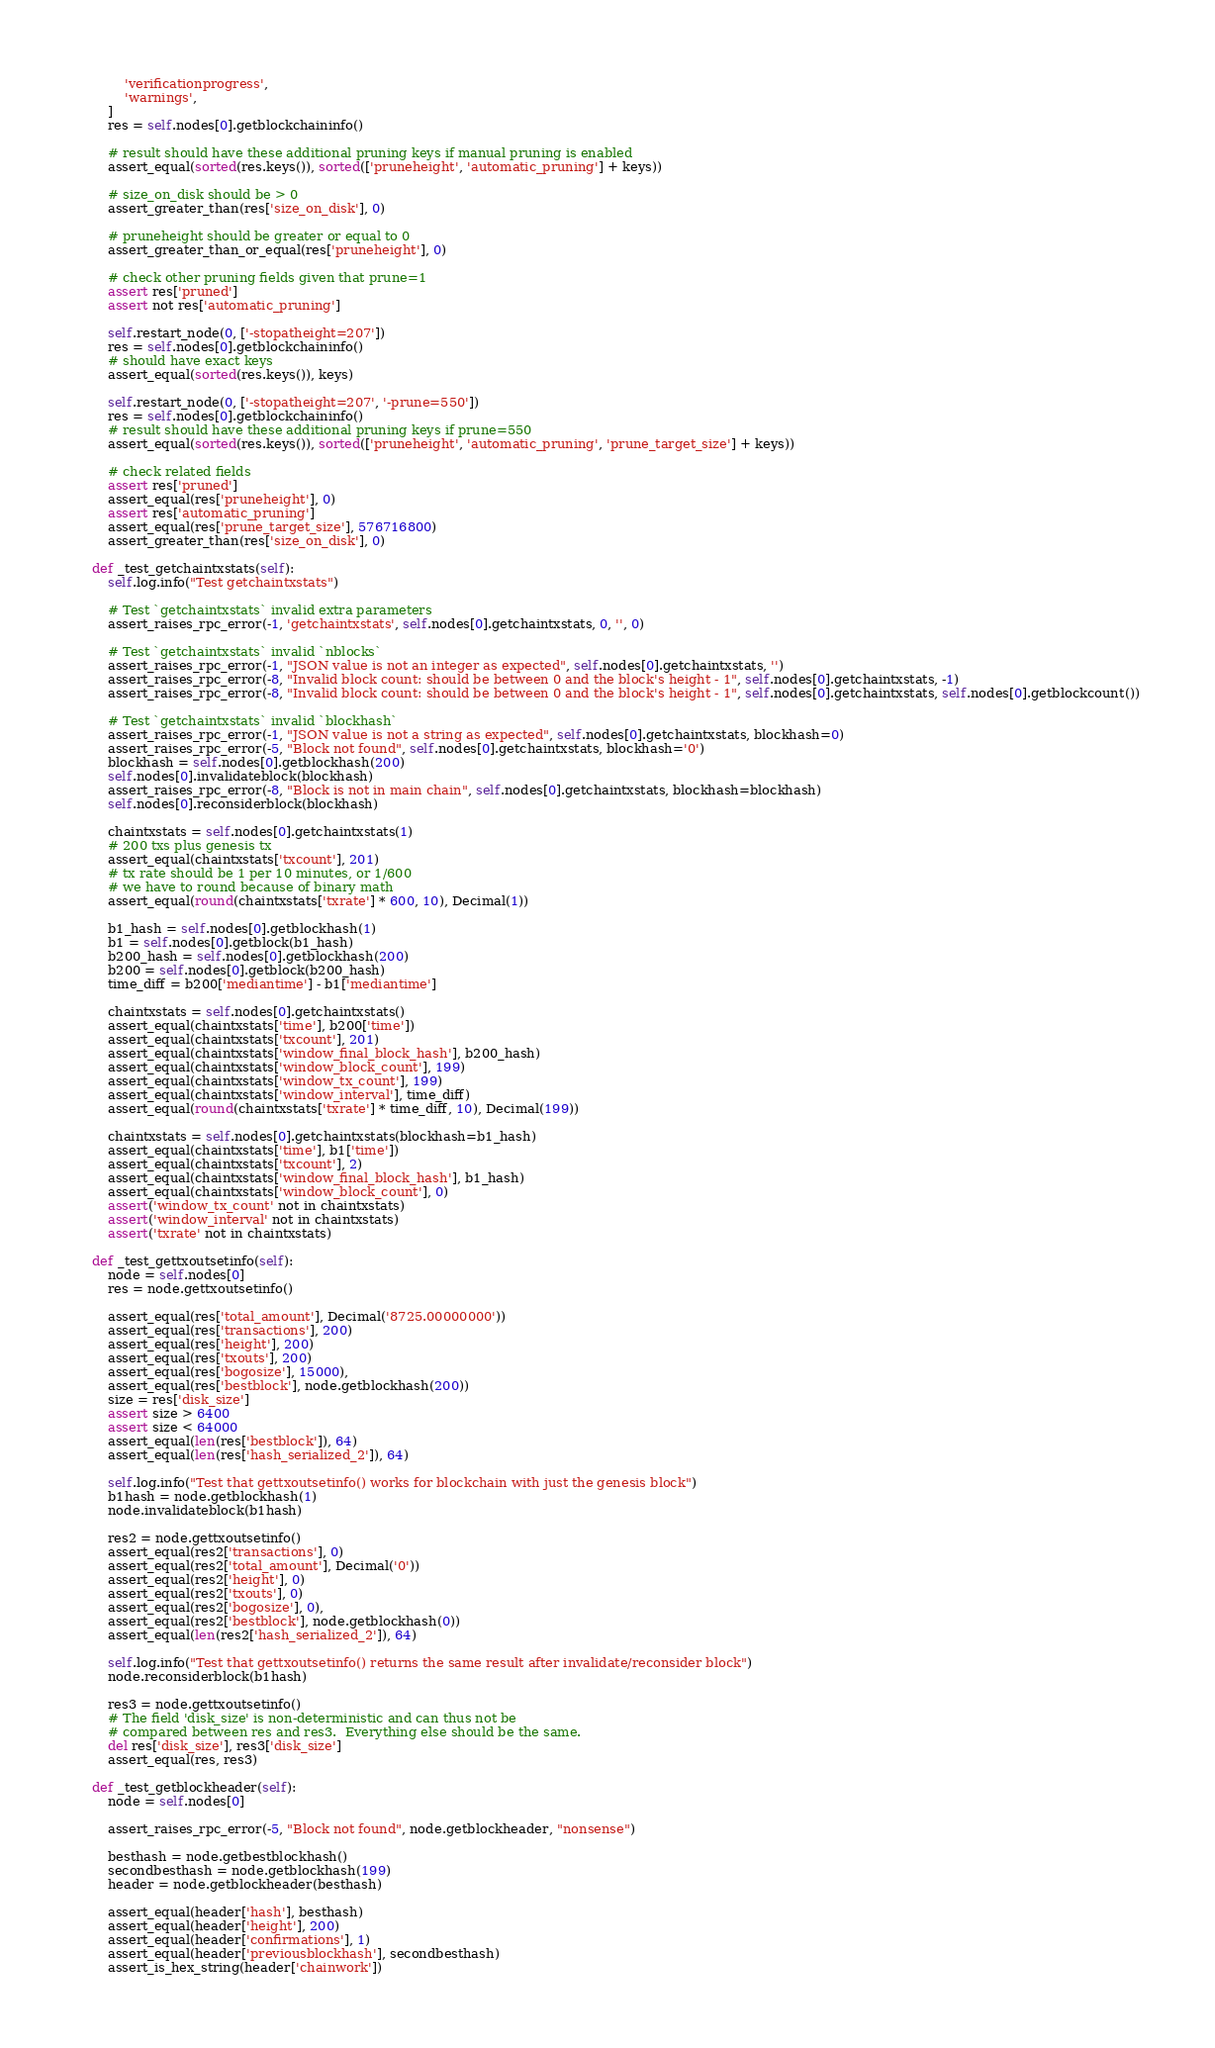<code> <loc_0><loc_0><loc_500><loc_500><_Python_>            'verificationprogress',
            'warnings',
        ]
        res = self.nodes[0].getblockchaininfo()

        # result should have these additional pruning keys if manual pruning is enabled
        assert_equal(sorted(res.keys()), sorted(['pruneheight', 'automatic_pruning'] + keys))

        # size_on_disk should be > 0
        assert_greater_than(res['size_on_disk'], 0)

        # pruneheight should be greater or equal to 0
        assert_greater_than_or_equal(res['pruneheight'], 0)

        # check other pruning fields given that prune=1
        assert res['pruned']
        assert not res['automatic_pruning']

        self.restart_node(0, ['-stopatheight=207'])
        res = self.nodes[0].getblockchaininfo()
        # should have exact keys
        assert_equal(sorted(res.keys()), keys)

        self.restart_node(0, ['-stopatheight=207', '-prune=550'])
        res = self.nodes[0].getblockchaininfo()
        # result should have these additional pruning keys if prune=550
        assert_equal(sorted(res.keys()), sorted(['pruneheight', 'automatic_pruning', 'prune_target_size'] + keys))

        # check related fields
        assert res['pruned']
        assert_equal(res['pruneheight'], 0)
        assert res['automatic_pruning']
        assert_equal(res['prune_target_size'], 576716800)
        assert_greater_than(res['size_on_disk'], 0)

    def _test_getchaintxstats(self):
        self.log.info("Test getchaintxstats")

        # Test `getchaintxstats` invalid extra parameters
        assert_raises_rpc_error(-1, 'getchaintxstats', self.nodes[0].getchaintxstats, 0, '', 0)

        # Test `getchaintxstats` invalid `nblocks`
        assert_raises_rpc_error(-1, "JSON value is not an integer as expected", self.nodes[0].getchaintxstats, '')
        assert_raises_rpc_error(-8, "Invalid block count: should be between 0 and the block's height - 1", self.nodes[0].getchaintxstats, -1)
        assert_raises_rpc_error(-8, "Invalid block count: should be between 0 and the block's height - 1", self.nodes[0].getchaintxstats, self.nodes[0].getblockcount())

        # Test `getchaintxstats` invalid `blockhash`
        assert_raises_rpc_error(-1, "JSON value is not a string as expected", self.nodes[0].getchaintxstats, blockhash=0)
        assert_raises_rpc_error(-5, "Block not found", self.nodes[0].getchaintxstats, blockhash='0')
        blockhash = self.nodes[0].getblockhash(200)
        self.nodes[0].invalidateblock(blockhash)
        assert_raises_rpc_error(-8, "Block is not in main chain", self.nodes[0].getchaintxstats, blockhash=blockhash)
        self.nodes[0].reconsiderblock(blockhash)

        chaintxstats = self.nodes[0].getchaintxstats(1)
        # 200 txs plus genesis tx
        assert_equal(chaintxstats['txcount'], 201)
        # tx rate should be 1 per 10 minutes, or 1/600
        # we have to round because of binary math
        assert_equal(round(chaintxstats['txrate'] * 600, 10), Decimal(1))

        b1_hash = self.nodes[0].getblockhash(1)
        b1 = self.nodes[0].getblock(b1_hash)
        b200_hash = self.nodes[0].getblockhash(200)
        b200 = self.nodes[0].getblock(b200_hash)
        time_diff = b200['mediantime'] - b1['mediantime']

        chaintxstats = self.nodes[0].getchaintxstats()
        assert_equal(chaintxstats['time'], b200['time'])
        assert_equal(chaintxstats['txcount'], 201)
        assert_equal(chaintxstats['window_final_block_hash'], b200_hash)
        assert_equal(chaintxstats['window_block_count'], 199)
        assert_equal(chaintxstats['window_tx_count'], 199)
        assert_equal(chaintxstats['window_interval'], time_diff)
        assert_equal(round(chaintxstats['txrate'] * time_diff, 10), Decimal(199))

        chaintxstats = self.nodes[0].getchaintxstats(blockhash=b1_hash)
        assert_equal(chaintxstats['time'], b1['time'])
        assert_equal(chaintxstats['txcount'], 2)
        assert_equal(chaintxstats['window_final_block_hash'], b1_hash)
        assert_equal(chaintxstats['window_block_count'], 0)
        assert('window_tx_count' not in chaintxstats)
        assert('window_interval' not in chaintxstats)
        assert('txrate' not in chaintxstats)

    def _test_gettxoutsetinfo(self):
        node = self.nodes[0]
        res = node.gettxoutsetinfo()

        assert_equal(res['total_amount'], Decimal('8725.00000000'))
        assert_equal(res['transactions'], 200)
        assert_equal(res['height'], 200)
        assert_equal(res['txouts'], 200)
        assert_equal(res['bogosize'], 15000),
        assert_equal(res['bestblock'], node.getblockhash(200))
        size = res['disk_size']
        assert size > 6400
        assert size < 64000
        assert_equal(len(res['bestblock']), 64)
        assert_equal(len(res['hash_serialized_2']), 64)

        self.log.info("Test that gettxoutsetinfo() works for blockchain with just the genesis block")
        b1hash = node.getblockhash(1)
        node.invalidateblock(b1hash)

        res2 = node.gettxoutsetinfo()
        assert_equal(res2['transactions'], 0)
        assert_equal(res2['total_amount'], Decimal('0'))
        assert_equal(res2['height'], 0)
        assert_equal(res2['txouts'], 0)
        assert_equal(res2['bogosize'], 0),
        assert_equal(res2['bestblock'], node.getblockhash(0))
        assert_equal(len(res2['hash_serialized_2']), 64)

        self.log.info("Test that gettxoutsetinfo() returns the same result after invalidate/reconsider block")
        node.reconsiderblock(b1hash)

        res3 = node.gettxoutsetinfo()
        # The field 'disk_size' is non-deterministic and can thus not be
        # compared between res and res3.  Everything else should be the same.
        del res['disk_size'], res3['disk_size']
        assert_equal(res, res3)

    def _test_getblockheader(self):
        node = self.nodes[0]

        assert_raises_rpc_error(-5, "Block not found", node.getblockheader, "nonsense")

        besthash = node.getbestblockhash()
        secondbesthash = node.getblockhash(199)
        header = node.getblockheader(besthash)

        assert_equal(header['hash'], besthash)
        assert_equal(header['height'], 200)
        assert_equal(header['confirmations'], 1)
        assert_equal(header['previousblockhash'], secondbesthash)
        assert_is_hex_string(header['chainwork'])</code> 